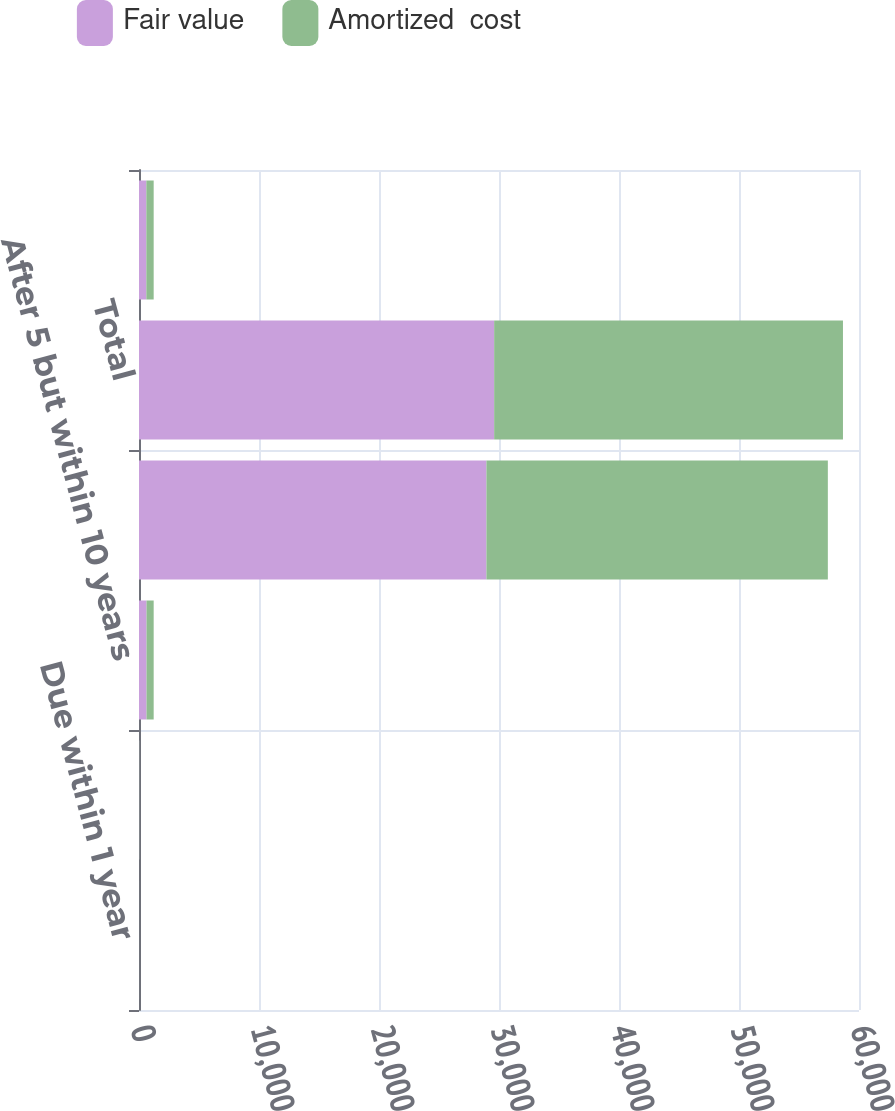Convert chart to OTSL. <chart><loc_0><loc_0><loc_500><loc_500><stacked_bar_chart><ecel><fcel>Due within 1 year<fcel>After 1 but within 5 years<fcel>After 5 but within 10 years<fcel>After 10 years (2)<fcel>Total<fcel>Total debt securities<nl><fcel>Fair value<fcel>2<fcel>16<fcel>626<fcel>28952<fcel>29596<fcel>611.5<nl><fcel>Amortized  cost<fcel>3<fcel>16<fcel>597<fcel>28452<fcel>29068<fcel>611.5<nl></chart> 